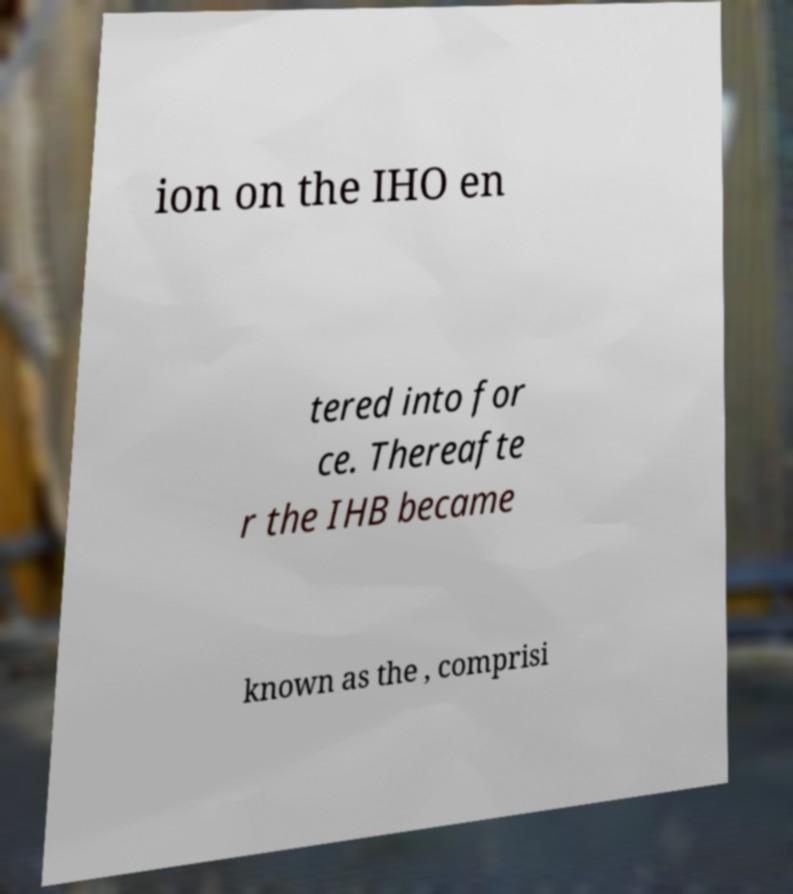Can you accurately transcribe the text from the provided image for me? ion on the IHO en tered into for ce. Thereafte r the IHB became known as the , comprisi 